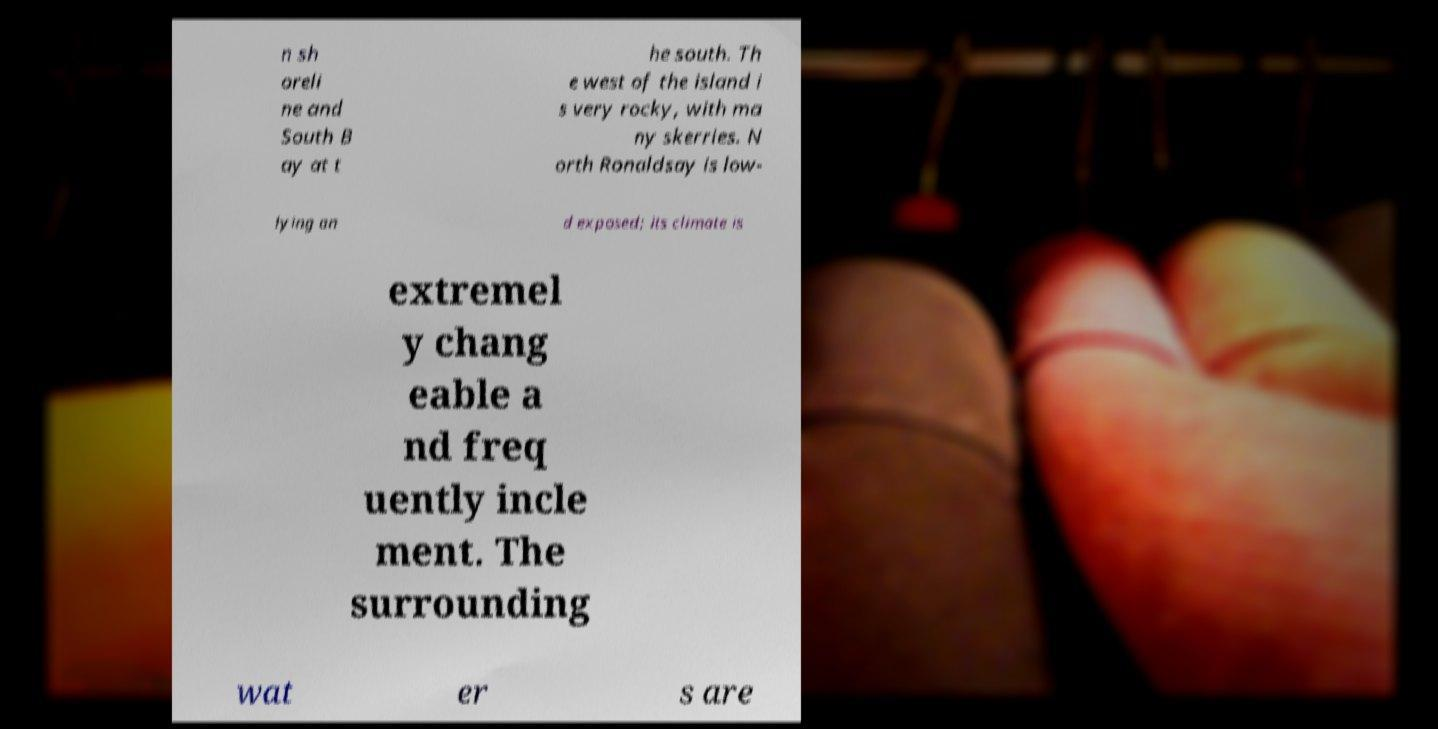Could you assist in decoding the text presented in this image and type it out clearly? n sh oreli ne and South B ay at t he south. Th e west of the island i s very rocky, with ma ny skerries. N orth Ronaldsay is low- lying an d exposed; its climate is extremel y chang eable a nd freq uently incle ment. The surrounding wat er s are 